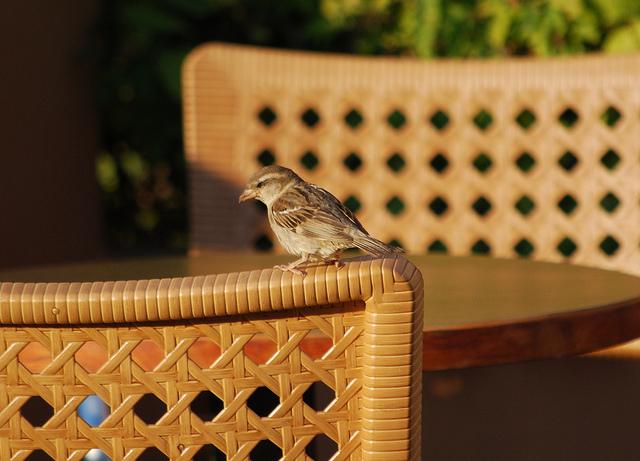Is the bird sitting on a chair?
Quick response, please. Yes. Which way is the bird facing?
Give a very brief answer. Left. Is this bird small?
Keep it brief. Yes. 